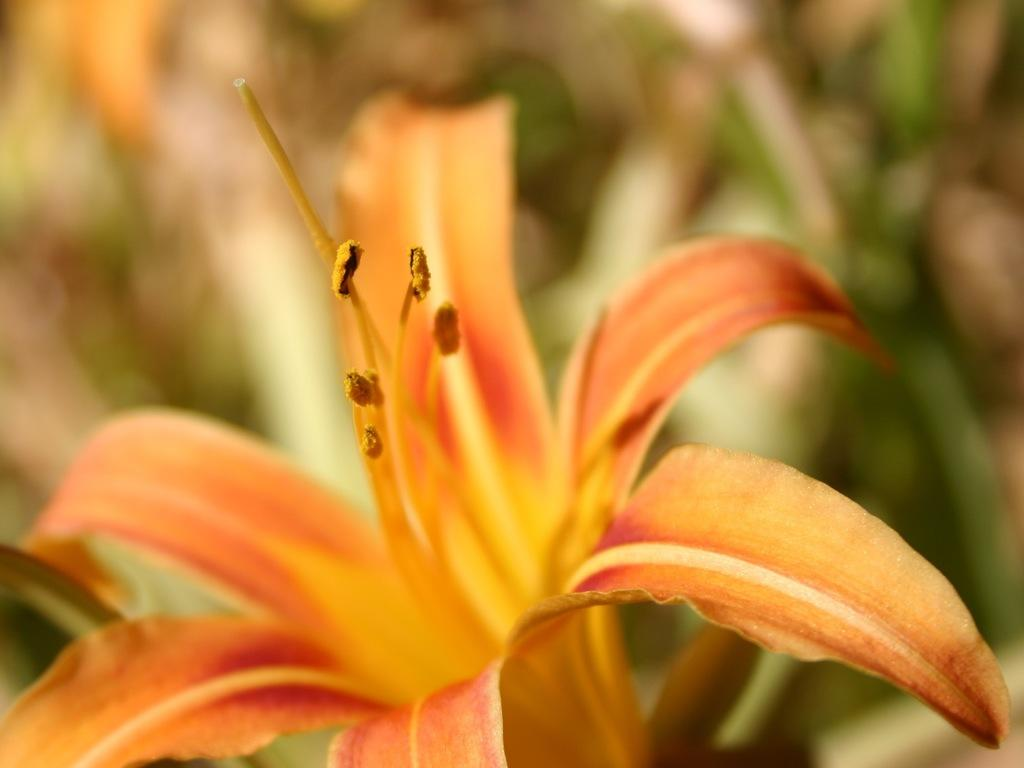What type of flower is present on the plant in the image? There is an orange flower on a plant in the image. What else can be seen on the left side of the image? There are leaves visible on the left side of the image. What type of beast is guarding its territory in the image? There is no beast or territory present in the image; it features an orange flower on a plant and leaves. 